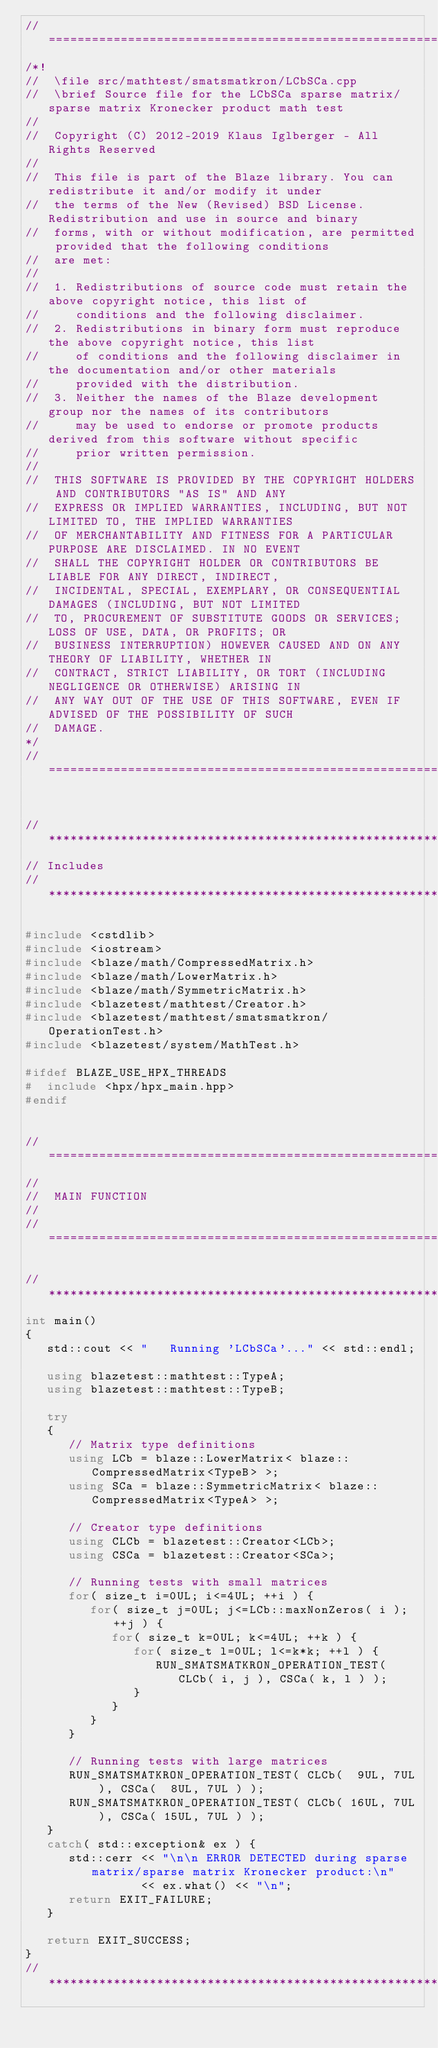<code> <loc_0><loc_0><loc_500><loc_500><_C++_>//=================================================================================================
/*!
//  \file src/mathtest/smatsmatkron/LCbSCa.cpp
//  \brief Source file for the LCbSCa sparse matrix/sparse matrix Kronecker product math test
//
//  Copyright (C) 2012-2019 Klaus Iglberger - All Rights Reserved
//
//  This file is part of the Blaze library. You can redistribute it and/or modify it under
//  the terms of the New (Revised) BSD License. Redistribution and use in source and binary
//  forms, with or without modification, are permitted provided that the following conditions
//  are met:
//
//  1. Redistributions of source code must retain the above copyright notice, this list of
//     conditions and the following disclaimer.
//  2. Redistributions in binary form must reproduce the above copyright notice, this list
//     of conditions and the following disclaimer in the documentation and/or other materials
//     provided with the distribution.
//  3. Neither the names of the Blaze development group nor the names of its contributors
//     may be used to endorse or promote products derived from this software without specific
//     prior written permission.
//
//  THIS SOFTWARE IS PROVIDED BY THE COPYRIGHT HOLDERS AND CONTRIBUTORS "AS IS" AND ANY
//  EXPRESS OR IMPLIED WARRANTIES, INCLUDING, BUT NOT LIMITED TO, THE IMPLIED WARRANTIES
//  OF MERCHANTABILITY AND FITNESS FOR A PARTICULAR PURPOSE ARE DISCLAIMED. IN NO EVENT
//  SHALL THE COPYRIGHT HOLDER OR CONTRIBUTORS BE LIABLE FOR ANY DIRECT, INDIRECT,
//  INCIDENTAL, SPECIAL, EXEMPLARY, OR CONSEQUENTIAL DAMAGES (INCLUDING, BUT NOT LIMITED
//  TO, PROCUREMENT OF SUBSTITUTE GOODS OR SERVICES; LOSS OF USE, DATA, OR PROFITS; OR
//  BUSINESS INTERRUPTION) HOWEVER CAUSED AND ON ANY THEORY OF LIABILITY, WHETHER IN
//  CONTRACT, STRICT LIABILITY, OR TORT (INCLUDING NEGLIGENCE OR OTHERWISE) ARISING IN
//  ANY WAY OUT OF THE USE OF THIS SOFTWARE, EVEN IF ADVISED OF THE POSSIBILITY OF SUCH
//  DAMAGE.
*/
//=================================================================================================


//*************************************************************************************************
// Includes
//*************************************************************************************************

#include <cstdlib>
#include <iostream>
#include <blaze/math/CompressedMatrix.h>
#include <blaze/math/LowerMatrix.h>
#include <blaze/math/SymmetricMatrix.h>
#include <blazetest/mathtest/Creator.h>
#include <blazetest/mathtest/smatsmatkron/OperationTest.h>
#include <blazetest/system/MathTest.h>

#ifdef BLAZE_USE_HPX_THREADS
#  include <hpx/hpx_main.hpp>
#endif


//=================================================================================================
//
//  MAIN FUNCTION
//
//=================================================================================================

//*************************************************************************************************
int main()
{
   std::cout << "   Running 'LCbSCa'..." << std::endl;

   using blazetest::mathtest::TypeA;
   using blazetest::mathtest::TypeB;

   try
   {
      // Matrix type definitions
      using LCb = blaze::LowerMatrix< blaze::CompressedMatrix<TypeB> >;
      using SCa = blaze::SymmetricMatrix< blaze::CompressedMatrix<TypeA> >;

      // Creator type definitions
      using CLCb = blazetest::Creator<LCb>;
      using CSCa = blazetest::Creator<SCa>;

      // Running tests with small matrices
      for( size_t i=0UL; i<=4UL; ++i ) {
         for( size_t j=0UL; j<=LCb::maxNonZeros( i ); ++j ) {
            for( size_t k=0UL; k<=4UL; ++k ) {
               for( size_t l=0UL; l<=k*k; ++l ) {
                  RUN_SMATSMATKRON_OPERATION_TEST( CLCb( i, j ), CSCa( k, l ) );
               }
            }
         }
      }

      // Running tests with large matrices
      RUN_SMATSMATKRON_OPERATION_TEST( CLCb(  9UL, 7UL ), CSCa(  8UL, 7UL ) );
      RUN_SMATSMATKRON_OPERATION_TEST( CLCb( 16UL, 7UL ), CSCa( 15UL, 7UL ) );
   }
   catch( std::exception& ex ) {
      std::cerr << "\n\n ERROR DETECTED during sparse matrix/sparse matrix Kronecker product:\n"
                << ex.what() << "\n";
      return EXIT_FAILURE;
   }

   return EXIT_SUCCESS;
}
//*************************************************************************************************
</code> 